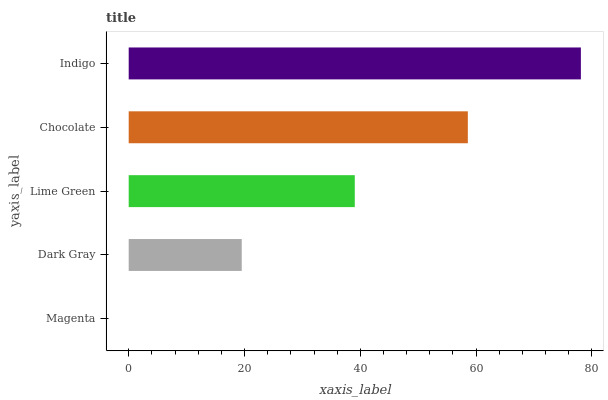Is Magenta the minimum?
Answer yes or no. Yes. Is Indigo the maximum?
Answer yes or no. Yes. Is Dark Gray the minimum?
Answer yes or no. No. Is Dark Gray the maximum?
Answer yes or no. No. Is Dark Gray greater than Magenta?
Answer yes or no. Yes. Is Magenta less than Dark Gray?
Answer yes or no. Yes. Is Magenta greater than Dark Gray?
Answer yes or no. No. Is Dark Gray less than Magenta?
Answer yes or no. No. Is Lime Green the high median?
Answer yes or no. Yes. Is Lime Green the low median?
Answer yes or no. Yes. Is Chocolate the high median?
Answer yes or no. No. Is Chocolate the low median?
Answer yes or no. No. 